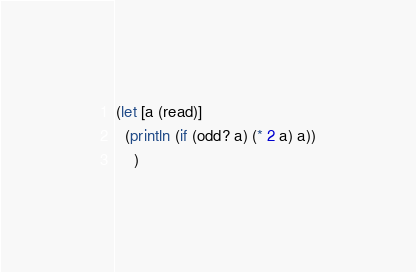<code> <loc_0><loc_0><loc_500><loc_500><_Clojure_>(let [a (read)]
  (println (if (odd? a) (* 2 a) a))
  	)</code> 